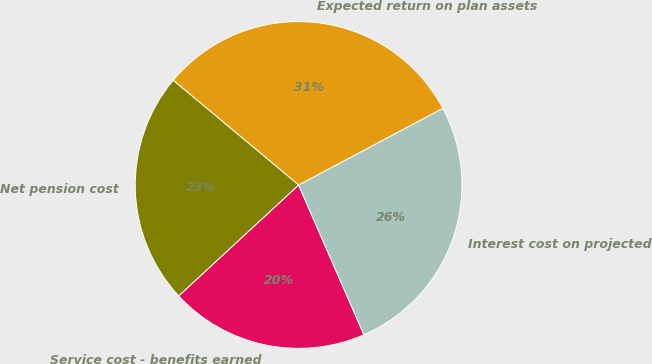<chart> <loc_0><loc_0><loc_500><loc_500><pie_chart><fcel>Service cost - benefits earned<fcel>Interest cost on projected<fcel>Expected return on plan assets<fcel>Net pension cost<nl><fcel>19.67%<fcel>26.23%<fcel>31.15%<fcel>22.95%<nl></chart> 